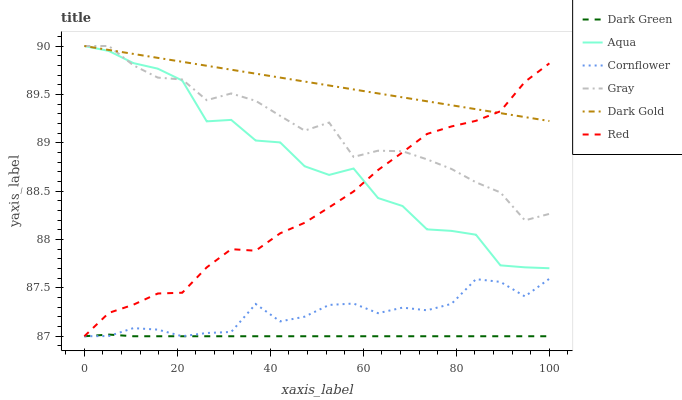Does Dark Green have the minimum area under the curve?
Answer yes or no. Yes. Does Dark Gold have the maximum area under the curve?
Answer yes or no. Yes. Does Gray have the minimum area under the curve?
Answer yes or no. No. Does Gray have the maximum area under the curve?
Answer yes or no. No. Is Dark Gold the smoothest?
Answer yes or no. Yes. Is Aqua the roughest?
Answer yes or no. Yes. Is Gray the smoothest?
Answer yes or no. No. Is Gray the roughest?
Answer yes or no. No. Does Cornflower have the lowest value?
Answer yes or no. Yes. Does Gray have the lowest value?
Answer yes or no. No. Does Aqua have the highest value?
Answer yes or no. Yes. Does Red have the highest value?
Answer yes or no. No. Is Dark Green less than Gray?
Answer yes or no. Yes. Is Dark Gold greater than Cornflower?
Answer yes or no. Yes. Does Dark Gold intersect Gray?
Answer yes or no. Yes. Is Dark Gold less than Gray?
Answer yes or no. No. Is Dark Gold greater than Gray?
Answer yes or no. No. Does Dark Green intersect Gray?
Answer yes or no. No. 